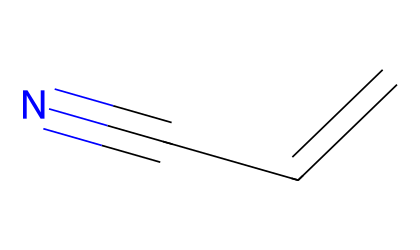What is the molecular formula of acrylonitrile? The structure consists of three carbon atoms, three hydrogen atoms, and one nitrogen atom. Thus, the molecular formula can be derived as C3H3N.
Answer: C3H3N How many carbon atoms are present in acrylonitrile? By examining the SMILES, there are three carbon atoms indicated in the molecular structure.
Answer: 3 What types of bonds does acrylonitrile contain? The structure features a double bond (C=C) and a triple bond (C#N); hence, acrylonitrile contains both double and triple bonds.
Answer: double and triple bonds What functional group is characteristic of acrylonitrile? The nitrile functional group is observed, represented by the -C#N feature in the structure.
Answer: nitrile What is the hybridization of the carbon atom in the nitrile group? The carbon in the nitrile group exhibits sp hybridization due to the triple bond with nitrogen, which requires the involvement of two sp orbitals from carbon.
Answer: sp Explain how the presence of the nitrile group affects the polarity of acrylonitrile. The nitrile group has a significant dipole moment because of the electronegativity difference between carbon and nitrogen, making acrylonitrile a polar molecule as a whole.
Answer: polar What unique property does acrylonitrile possess due to its structure? Because of its unsaturation from the double bond and the electronegative nitrogen in the nitrile group, acrylonitrile is reactive and can undergo polymerization.
Answer: reactive 